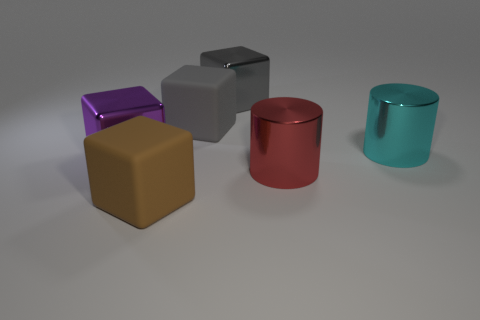What number of objects are either large matte things behind the red cylinder or red metallic objects?
Your response must be concise. 2. Are there fewer big brown blocks than small gray spheres?
Your answer should be compact. No. What is the shape of the purple object that is made of the same material as the cyan cylinder?
Keep it short and to the point. Cube. Are there any gray things to the left of the brown matte cube?
Give a very brief answer. No. Are there fewer brown objects in front of the brown rubber block than small brown matte blocks?
Give a very brief answer. No. What is the large cyan cylinder made of?
Your answer should be compact. Metal. There is a big object that is in front of the cyan cylinder and to the right of the large brown thing; what is its color?
Make the answer very short. Red. Are there any other things that are the same material as the big brown cube?
Keep it short and to the point. Yes. Does the big red thing have the same material as the brown block that is in front of the big gray shiny block?
Your response must be concise. No. What size is the matte block in front of the metal cylinder right of the red thing?
Your response must be concise. Large. 